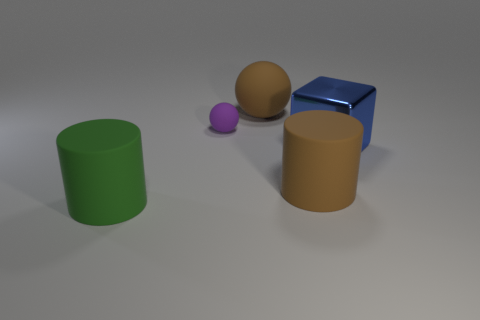Add 2 balls. How many objects exist? 7 Subtract all balls. How many objects are left? 3 Add 1 brown rubber things. How many brown rubber things are left? 3 Add 3 large green things. How many large green things exist? 4 Subtract 0 green spheres. How many objects are left? 5 Subtract all brown cylinders. Subtract all brown things. How many objects are left? 2 